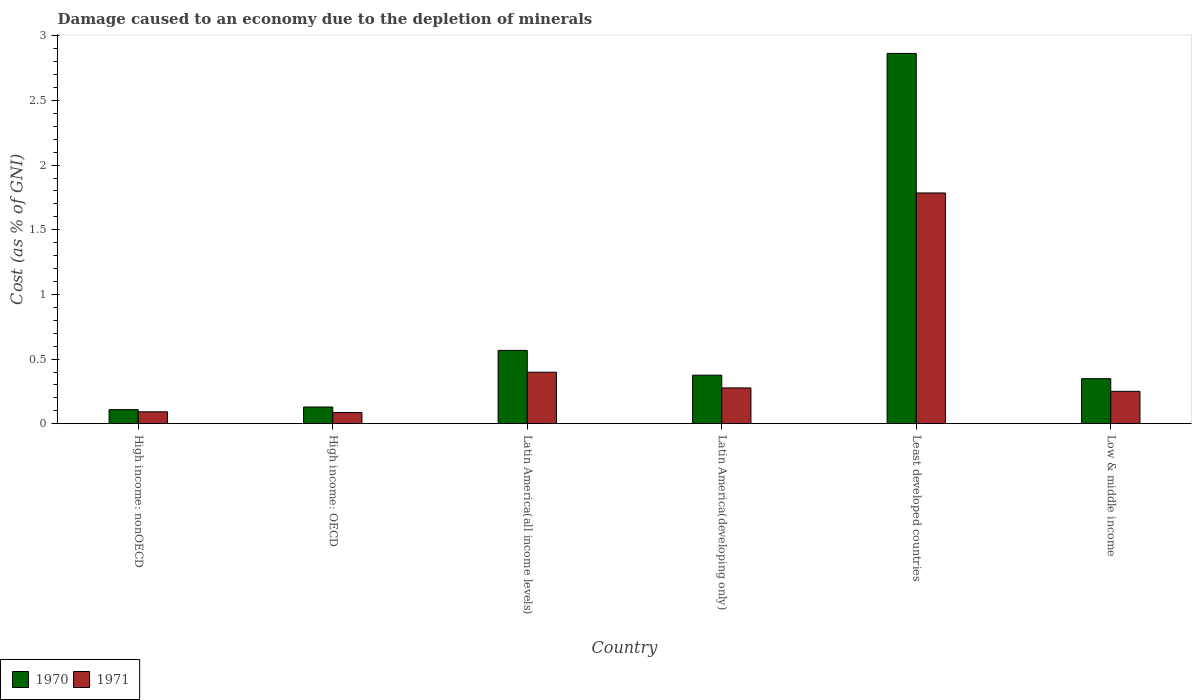How many groups of bars are there?
Give a very brief answer. 6. Are the number of bars per tick equal to the number of legend labels?
Your answer should be compact. Yes. What is the label of the 6th group of bars from the left?
Ensure brevity in your answer.  Low & middle income. In how many cases, is the number of bars for a given country not equal to the number of legend labels?
Ensure brevity in your answer.  0. What is the cost of damage caused due to the depletion of minerals in 1970 in High income: OECD?
Ensure brevity in your answer.  0.13. Across all countries, what is the maximum cost of damage caused due to the depletion of minerals in 1971?
Make the answer very short. 1.78. Across all countries, what is the minimum cost of damage caused due to the depletion of minerals in 1970?
Your answer should be very brief. 0.11. In which country was the cost of damage caused due to the depletion of minerals in 1970 maximum?
Your answer should be very brief. Least developed countries. In which country was the cost of damage caused due to the depletion of minerals in 1970 minimum?
Your answer should be compact. High income: nonOECD. What is the total cost of damage caused due to the depletion of minerals in 1970 in the graph?
Ensure brevity in your answer.  4.39. What is the difference between the cost of damage caused due to the depletion of minerals in 1970 in High income: nonOECD and that in Latin America(all income levels)?
Keep it short and to the point. -0.46. What is the difference between the cost of damage caused due to the depletion of minerals in 1970 in High income: OECD and the cost of damage caused due to the depletion of minerals in 1971 in High income: nonOECD?
Your answer should be compact. 0.04. What is the average cost of damage caused due to the depletion of minerals in 1970 per country?
Offer a very short reply. 0.73. What is the difference between the cost of damage caused due to the depletion of minerals of/in 1970 and cost of damage caused due to the depletion of minerals of/in 1971 in High income: OECD?
Your answer should be compact. 0.04. What is the ratio of the cost of damage caused due to the depletion of minerals in 1970 in High income: nonOECD to that in Latin America(all income levels)?
Provide a short and direct response. 0.19. Is the cost of damage caused due to the depletion of minerals in 1970 in High income: nonOECD less than that in Latin America(developing only)?
Your answer should be very brief. Yes. What is the difference between the highest and the second highest cost of damage caused due to the depletion of minerals in 1971?
Provide a succinct answer. -1.39. What is the difference between the highest and the lowest cost of damage caused due to the depletion of minerals in 1971?
Offer a very short reply. 1.7. Is the sum of the cost of damage caused due to the depletion of minerals in 1971 in High income: OECD and High income: nonOECD greater than the maximum cost of damage caused due to the depletion of minerals in 1970 across all countries?
Offer a terse response. No. What does the 2nd bar from the right in Least developed countries represents?
Your response must be concise. 1970. How many bars are there?
Make the answer very short. 12. How many countries are there in the graph?
Your answer should be compact. 6. Does the graph contain any zero values?
Your answer should be compact. No. Does the graph contain grids?
Make the answer very short. No. How are the legend labels stacked?
Keep it short and to the point. Horizontal. What is the title of the graph?
Make the answer very short. Damage caused to an economy due to the depletion of minerals. What is the label or title of the X-axis?
Make the answer very short. Country. What is the label or title of the Y-axis?
Give a very brief answer. Cost (as % of GNI). What is the Cost (as % of GNI) in 1970 in High income: nonOECD?
Ensure brevity in your answer.  0.11. What is the Cost (as % of GNI) in 1971 in High income: nonOECD?
Provide a succinct answer. 0.09. What is the Cost (as % of GNI) of 1970 in High income: OECD?
Keep it short and to the point. 0.13. What is the Cost (as % of GNI) in 1971 in High income: OECD?
Your answer should be compact. 0.09. What is the Cost (as % of GNI) of 1970 in Latin America(all income levels)?
Keep it short and to the point. 0.57. What is the Cost (as % of GNI) of 1971 in Latin America(all income levels)?
Keep it short and to the point. 0.4. What is the Cost (as % of GNI) of 1970 in Latin America(developing only)?
Ensure brevity in your answer.  0.38. What is the Cost (as % of GNI) of 1971 in Latin America(developing only)?
Provide a short and direct response. 0.28. What is the Cost (as % of GNI) in 1970 in Least developed countries?
Keep it short and to the point. 2.86. What is the Cost (as % of GNI) in 1971 in Least developed countries?
Make the answer very short. 1.78. What is the Cost (as % of GNI) in 1970 in Low & middle income?
Offer a terse response. 0.35. What is the Cost (as % of GNI) in 1971 in Low & middle income?
Give a very brief answer. 0.25. Across all countries, what is the maximum Cost (as % of GNI) in 1970?
Offer a very short reply. 2.86. Across all countries, what is the maximum Cost (as % of GNI) in 1971?
Offer a terse response. 1.78. Across all countries, what is the minimum Cost (as % of GNI) of 1970?
Provide a succinct answer. 0.11. Across all countries, what is the minimum Cost (as % of GNI) of 1971?
Keep it short and to the point. 0.09. What is the total Cost (as % of GNI) in 1970 in the graph?
Provide a succinct answer. 4.39. What is the total Cost (as % of GNI) of 1971 in the graph?
Provide a short and direct response. 2.89. What is the difference between the Cost (as % of GNI) of 1970 in High income: nonOECD and that in High income: OECD?
Ensure brevity in your answer.  -0.02. What is the difference between the Cost (as % of GNI) in 1971 in High income: nonOECD and that in High income: OECD?
Your answer should be compact. 0.01. What is the difference between the Cost (as % of GNI) of 1970 in High income: nonOECD and that in Latin America(all income levels)?
Make the answer very short. -0.46. What is the difference between the Cost (as % of GNI) in 1971 in High income: nonOECD and that in Latin America(all income levels)?
Ensure brevity in your answer.  -0.31. What is the difference between the Cost (as % of GNI) of 1970 in High income: nonOECD and that in Latin America(developing only)?
Your answer should be very brief. -0.27. What is the difference between the Cost (as % of GNI) in 1971 in High income: nonOECD and that in Latin America(developing only)?
Your answer should be compact. -0.18. What is the difference between the Cost (as % of GNI) of 1970 in High income: nonOECD and that in Least developed countries?
Offer a very short reply. -2.75. What is the difference between the Cost (as % of GNI) in 1971 in High income: nonOECD and that in Least developed countries?
Provide a short and direct response. -1.69. What is the difference between the Cost (as % of GNI) of 1970 in High income: nonOECD and that in Low & middle income?
Your response must be concise. -0.24. What is the difference between the Cost (as % of GNI) of 1971 in High income: nonOECD and that in Low & middle income?
Provide a succinct answer. -0.16. What is the difference between the Cost (as % of GNI) in 1970 in High income: OECD and that in Latin America(all income levels)?
Your answer should be compact. -0.44. What is the difference between the Cost (as % of GNI) in 1971 in High income: OECD and that in Latin America(all income levels)?
Your answer should be very brief. -0.31. What is the difference between the Cost (as % of GNI) in 1970 in High income: OECD and that in Latin America(developing only)?
Your answer should be compact. -0.25. What is the difference between the Cost (as % of GNI) of 1971 in High income: OECD and that in Latin America(developing only)?
Give a very brief answer. -0.19. What is the difference between the Cost (as % of GNI) in 1970 in High income: OECD and that in Least developed countries?
Provide a succinct answer. -2.73. What is the difference between the Cost (as % of GNI) of 1971 in High income: OECD and that in Least developed countries?
Your response must be concise. -1.7. What is the difference between the Cost (as % of GNI) in 1970 in High income: OECD and that in Low & middle income?
Your answer should be compact. -0.22. What is the difference between the Cost (as % of GNI) of 1971 in High income: OECD and that in Low & middle income?
Make the answer very short. -0.16. What is the difference between the Cost (as % of GNI) of 1970 in Latin America(all income levels) and that in Latin America(developing only)?
Provide a short and direct response. 0.19. What is the difference between the Cost (as % of GNI) of 1971 in Latin America(all income levels) and that in Latin America(developing only)?
Make the answer very short. 0.12. What is the difference between the Cost (as % of GNI) of 1970 in Latin America(all income levels) and that in Least developed countries?
Provide a short and direct response. -2.3. What is the difference between the Cost (as % of GNI) in 1971 in Latin America(all income levels) and that in Least developed countries?
Offer a terse response. -1.39. What is the difference between the Cost (as % of GNI) of 1970 in Latin America(all income levels) and that in Low & middle income?
Provide a succinct answer. 0.22. What is the difference between the Cost (as % of GNI) of 1971 in Latin America(all income levels) and that in Low & middle income?
Your answer should be very brief. 0.15. What is the difference between the Cost (as % of GNI) in 1970 in Latin America(developing only) and that in Least developed countries?
Your answer should be very brief. -2.49. What is the difference between the Cost (as % of GNI) in 1971 in Latin America(developing only) and that in Least developed countries?
Provide a succinct answer. -1.51. What is the difference between the Cost (as % of GNI) in 1970 in Latin America(developing only) and that in Low & middle income?
Give a very brief answer. 0.03. What is the difference between the Cost (as % of GNI) of 1971 in Latin America(developing only) and that in Low & middle income?
Provide a succinct answer. 0.03. What is the difference between the Cost (as % of GNI) in 1970 in Least developed countries and that in Low & middle income?
Keep it short and to the point. 2.52. What is the difference between the Cost (as % of GNI) of 1971 in Least developed countries and that in Low & middle income?
Provide a succinct answer. 1.53. What is the difference between the Cost (as % of GNI) of 1970 in High income: nonOECD and the Cost (as % of GNI) of 1971 in High income: OECD?
Provide a succinct answer. 0.02. What is the difference between the Cost (as % of GNI) of 1970 in High income: nonOECD and the Cost (as % of GNI) of 1971 in Latin America(all income levels)?
Keep it short and to the point. -0.29. What is the difference between the Cost (as % of GNI) of 1970 in High income: nonOECD and the Cost (as % of GNI) of 1971 in Latin America(developing only)?
Your response must be concise. -0.17. What is the difference between the Cost (as % of GNI) in 1970 in High income: nonOECD and the Cost (as % of GNI) in 1971 in Least developed countries?
Your response must be concise. -1.68. What is the difference between the Cost (as % of GNI) of 1970 in High income: nonOECD and the Cost (as % of GNI) of 1971 in Low & middle income?
Offer a terse response. -0.14. What is the difference between the Cost (as % of GNI) of 1970 in High income: OECD and the Cost (as % of GNI) of 1971 in Latin America(all income levels)?
Keep it short and to the point. -0.27. What is the difference between the Cost (as % of GNI) of 1970 in High income: OECD and the Cost (as % of GNI) of 1971 in Latin America(developing only)?
Provide a short and direct response. -0.15. What is the difference between the Cost (as % of GNI) in 1970 in High income: OECD and the Cost (as % of GNI) in 1971 in Least developed countries?
Keep it short and to the point. -1.66. What is the difference between the Cost (as % of GNI) of 1970 in High income: OECD and the Cost (as % of GNI) of 1971 in Low & middle income?
Offer a terse response. -0.12. What is the difference between the Cost (as % of GNI) of 1970 in Latin America(all income levels) and the Cost (as % of GNI) of 1971 in Latin America(developing only)?
Offer a terse response. 0.29. What is the difference between the Cost (as % of GNI) of 1970 in Latin America(all income levels) and the Cost (as % of GNI) of 1971 in Least developed countries?
Your response must be concise. -1.22. What is the difference between the Cost (as % of GNI) in 1970 in Latin America(all income levels) and the Cost (as % of GNI) in 1971 in Low & middle income?
Provide a succinct answer. 0.32. What is the difference between the Cost (as % of GNI) of 1970 in Latin America(developing only) and the Cost (as % of GNI) of 1971 in Least developed countries?
Your response must be concise. -1.41. What is the difference between the Cost (as % of GNI) in 1970 in Latin America(developing only) and the Cost (as % of GNI) in 1971 in Low & middle income?
Ensure brevity in your answer.  0.12. What is the difference between the Cost (as % of GNI) of 1970 in Least developed countries and the Cost (as % of GNI) of 1971 in Low & middle income?
Your answer should be compact. 2.61. What is the average Cost (as % of GNI) in 1970 per country?
Offer a terse response. 0.73. What is the average Cost (as % of GNI) of 1971 per country?
Your answer should be compact. 0.48. What is the difference between the Cost (as % of GNI) in 1970 and Cost (as % of GNI) in 1971 in High income: nonOECD?
Make the answer very short. 0.02. What is the difference between the Cost (as % of GNI) in 1970 and Cost (as % of GNI) in 1971 in High income: OECD?
Provide a short and direct response. 0.04. What is the difference between the Cost (as % of GNI) of 1970 and Cost (as % of GNI) of 1971 in Latin America(all income levels)?
Offer a terse response. 0.17. What is the difference between the Cost (as % of GNI) in 1970 and Cost (as % of GNI) in 1971 in Latin America(developing only)?
Your response must be concise. 0.1. What is the difference between the Cost (as % of GNI) of 1970 and Cost (as % of GNI) of 1971 in Least developed countries?
Offer a terse response. 1.08. What is the difference between the Cost (as % of GNI) of 1970 and Cost (as % of GNI) of 1971 in Low & middle income?
Offer a terse response. 0.1. What is the ratio of the Cost (as % of GNI) of 1970 in High income: nonOECD to that in High income: OECD?
Your response must be concise. 0.84. What is the ratio of the Cost (as % of GNI) in 1971 in High income: nonOECD to that in High income: OECD?
Offer a terse response. 1.07. What is the ratio of the Cost (as % of GNI) in 1970 in High income: nonOECD to that in Latin America(all income levels)?
Give a very brief answer. 0.19. What is the ratio of the Cost (as % of GNI) of 1971 in High income: nonOECD to that in Latin America(all income levels)?
Provide a short and direct response. 0.23. What is the ratio of the Cost (as % of GNI) of 1970 in High income: nonOECD to that in Latin America(developing only)?
Keep it short and to the point. 0.29. What is the ratio of the Cost (as % of GNI) in 1971 in High income: nonOECD to that in Latin America(developing only)?
Offer a terse response. 0.33. What is the ratio of the Cost (as % of GNI) in 1970 in High income: nonOECD to that in Least developed countries?
Ensure brevity in your answer.  0.04. What is the ratio of the Cost (as % of GNI) of 1971 in High income: nonOECD to that in Least developed countries?
Your response must be concise. 0.05. What is the ratio of the Cost (as % of GNI) of 1970 in High income: nonOECD to that in Low & middle income?
Provide a succinct answer. 0.31. What is the ratio of the Cost (as % of GNI) in 1971 in High income: nonOECD to that in Low & middle income?
Ensure brevity in your answer.  0.37. What is the ratio of the Cost (as % of GNI) of 1970 in High income: OECD to that in Latin America(all income levels)?
Your answer should be compact. 0.23. What is the ratio of the Cost (as % of GNI) of 1971 in High income: OECD to that in Latin America(all income levels)?
Offer a very short reply. 0.22. What is the ratio of the Cost (as % of GNI) of 1970 in High income: OECD to that in Latin America(developing only)?
Give a very brief answer. 0.34. What is the ratio of the Cost (as % of GNI) of 1971 in High income: OECD to that in Latin America(developing only)?
Provide a short and direct response. 0.31. What is the ratio of the Cost (as % of GNI) of 1970 in High income: OECD to that in Least developed countries?
Provide a short and direct response. 0.05. What is the ratio of the Cost (as % of GNI) in 1971 in High income: OECD to that in Least developed countries?
Offer a terse response. 0.05. What is the ratio of the Cost (as % of GNI) in 1970 in High income: OECD to that in Low & middle income?
Your response must be concise. 0.37. What is the ratio of the Cost (as % of GNI) in 1971 in High income: OECD to that in Low & middle income?
Offer a terse response. 0.34. What is the ratio of the Cost (as % of GNI) of 1970 in Latin America(all income levels) to that in Latin America(developing only)?
Provide a short and direct response. 1.51. What is the ratio of the Cost (as % of GNI) of 1971 in Latin America(all income levels) to that in Latin America(developing only)?
Provide a short and direct response. 1.44. What is the ratio of the Cost (as % of GNI) of 1970 in Latin America(all income levels) to that in Least developed countries?
Keep it short and to the point. 0.2. What is the ratio of the Cost (as % of GNI) in 1971 in Latin America(all income levels) to that in Least developed countries?
Provide a succinct answer. 0.22. What is the ratio of the Cost (as % of GNI) of 1970 in Latin America(all income levels) to that in Low & middle income?
Offer a terse response. 1.63. What is the ratio of the Cost (as % of GNI) of 1971 in Latin America(all income levels) to that in Low & middle income?
Offer a very short reply. 1.59. What is the ratio of the Cost (as % of GNI) of 1970 in Latin America(developing only) to that in Least developed countries?
Your answer should be compact. 0.13. What is the ratio of the Cost (as % of GNI) in 1971 in Latin America(developing only) to that in Least developed countries?
Provide a succinct answer. 0.16. What is the ratio of the Cost (as % of GNI) of 1970 in Latin America(developing only) to that in Low & middle income?
Your response must be concise. 1.08. What is the ratio of the Cost (as % of GNI) in 1971 in Latin America(developing only) to that in Low & middle income?
Provide a short and direct response. 1.11. What is the ratio of the Cost (as % of GNI) of 1970 in Least developed countries to that in Low & middle income?
Your answer should be very brief. 8.22. What is the ratio of the Cost (as % of GNI) in 1971 in Least developed countries to that in Low & middle income?
Give a very brief answer. 7.12. What is the difference between the highest and the second highest Cost (as % of GNI) of 1970?
Provide a succinct answer. 2.3. What is the difference between the highest and the second highest Cost (as % of GNI) of 1971?
Ensure brevity in your answer.  1.39. What is the difference between the highest and the lowest Cost (as % of GNI) in 1970?
Offer a terse response. 2.75. What is the difference between the highest and the lowest Cost (as % of GNI) in 1971?
Make the answer very short. 1.7. 